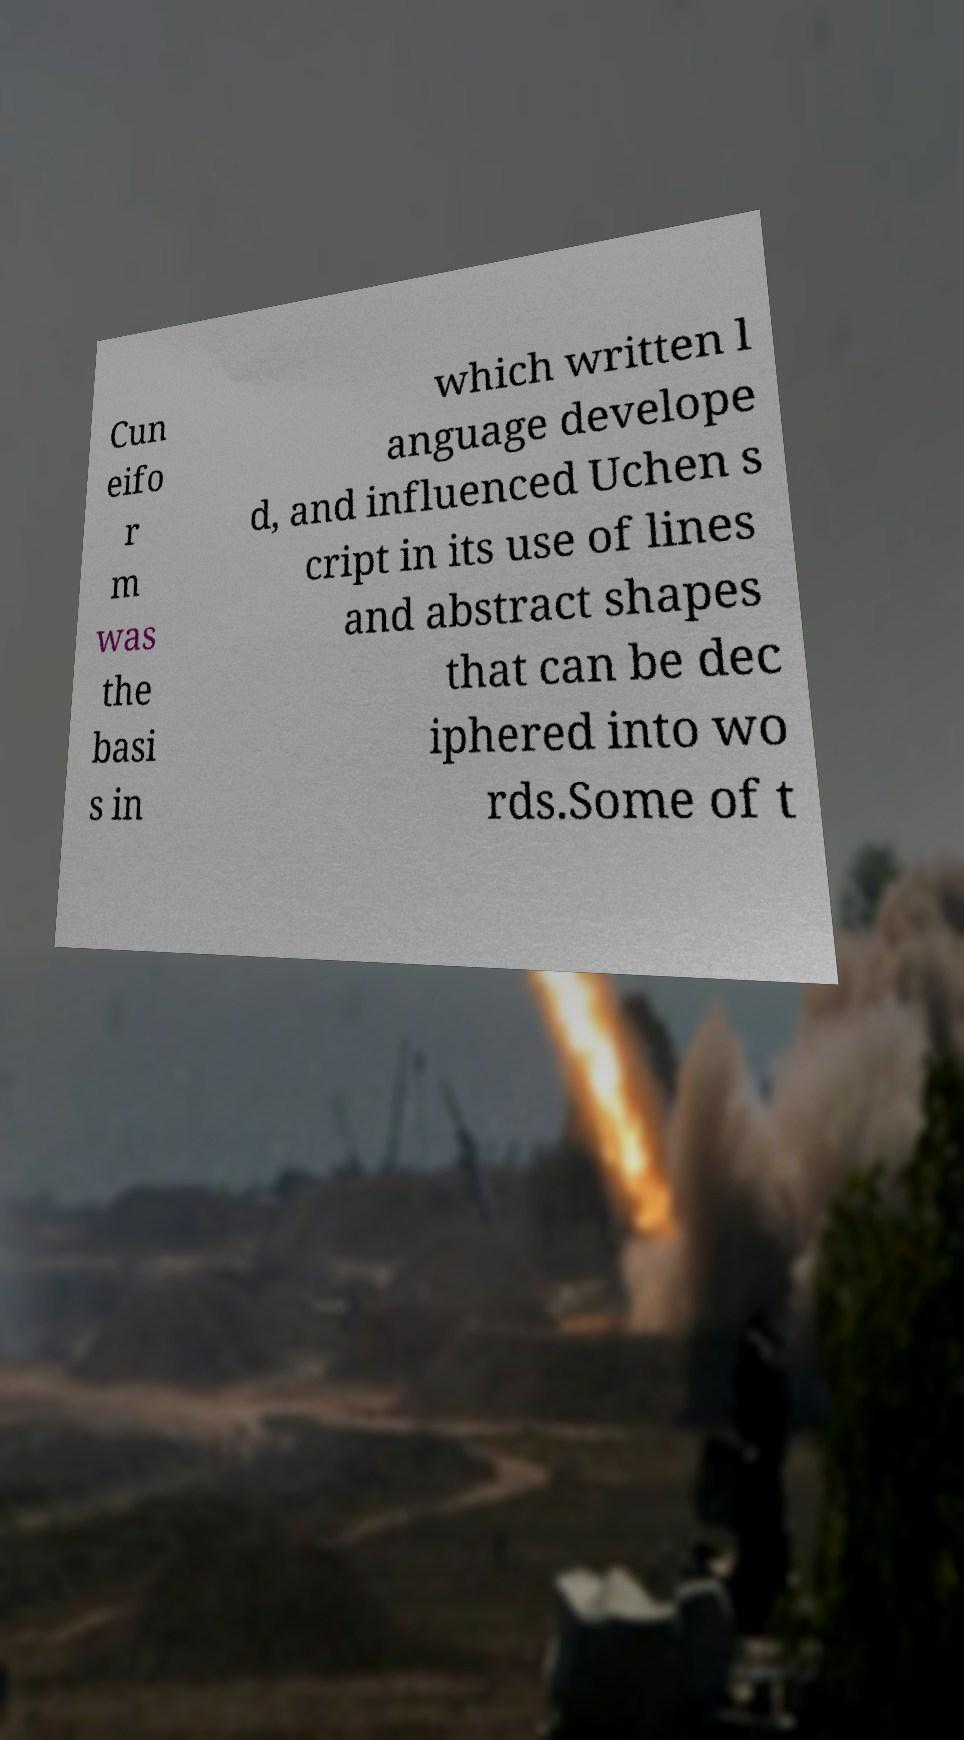Please read and relay the text visible in this image. What does it say? Cun eifo r m was the basi s in which written l anguage develope d, and influenced Uchen s cript in its use of lines and abstract shapes that can be dec iphered into wo rds.Some of t 